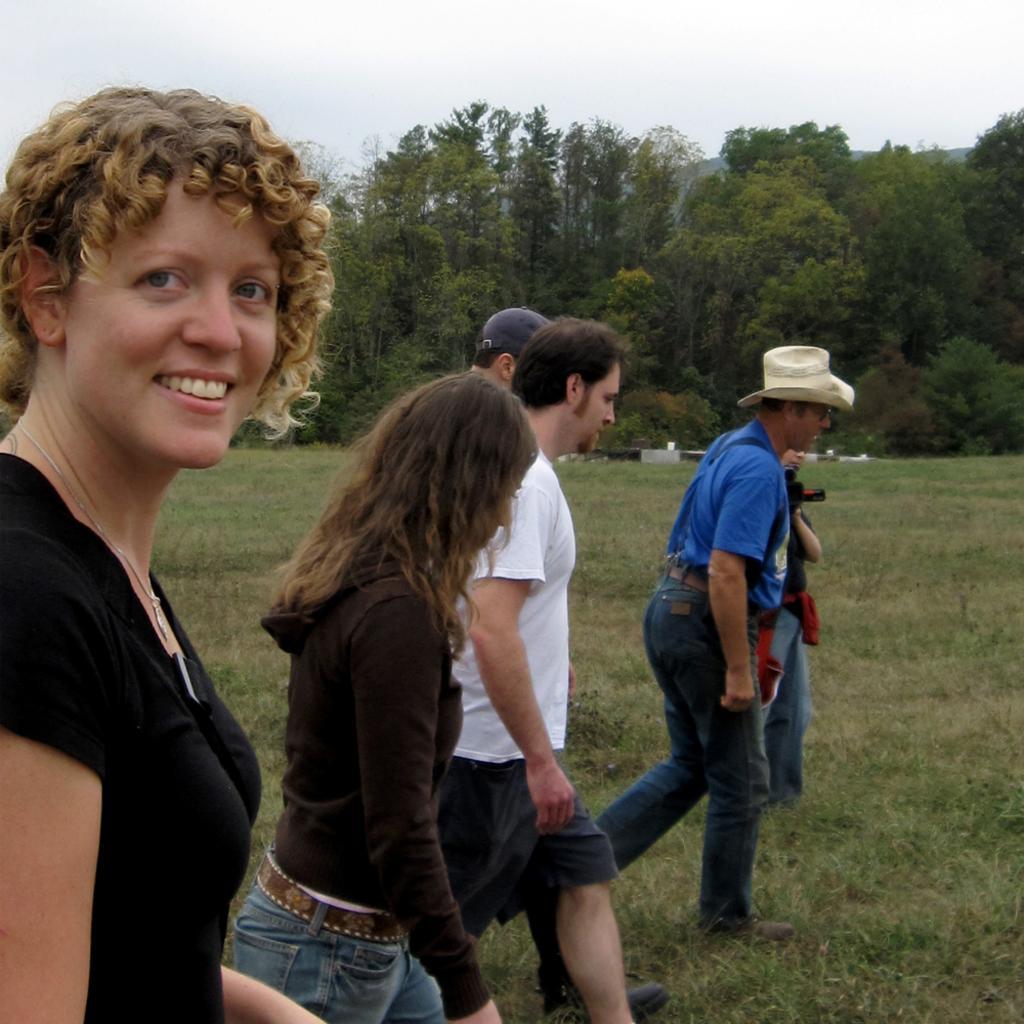Can you describe this image briefly? In this picture we can see some people are walking, a woman in the front is smiling, at the bottom there is grass, we can see trees in the background, there is the sky at the top of the picture. 